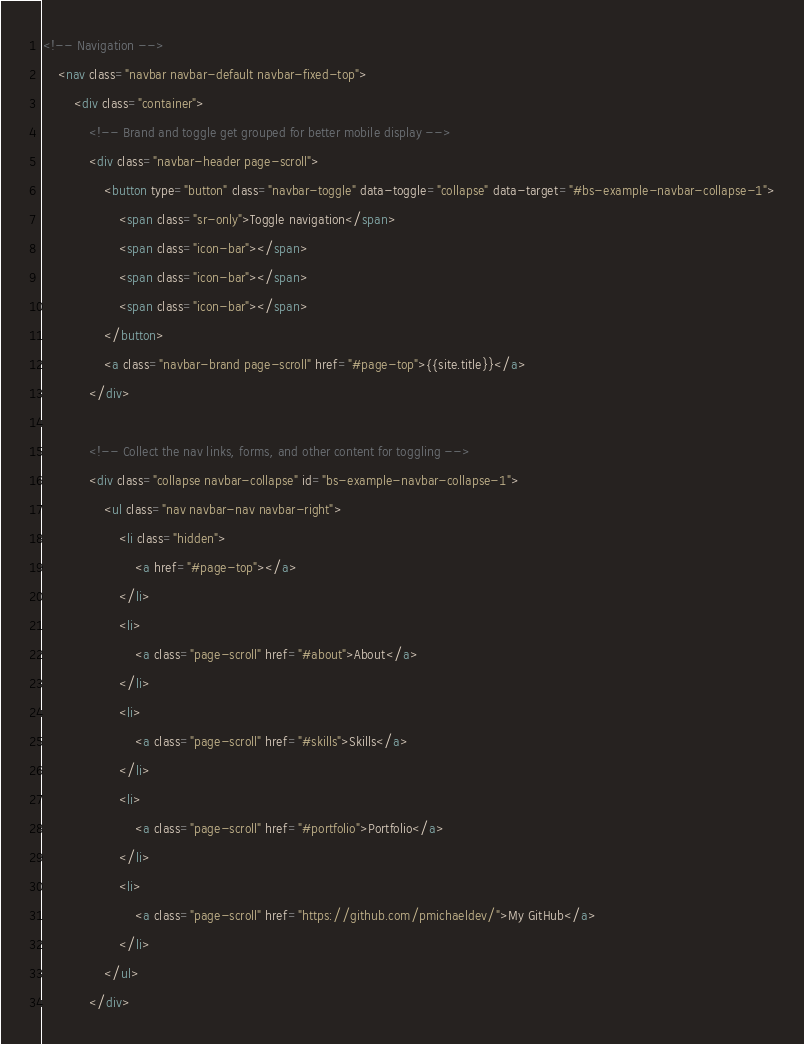Convert code to text. <code><loc_0><loc_0><loc_500><loc_500><_HTML_><!-- Navigation -->
    <nav class="navbar navbar-default navbar-fixed-top">
        <div class="container">
            <!-- Brand and toggle get grouped for better mobile display -->
            <div class="navbar-header page-scroll">
                <button type="button" class="navbar-toggle" data-toggle="collapse" data-target="#bs-example-navbar-collapse-1">
                    <span class="sr-only">Toggle navigation</span>
                    <span class="icon-bar"></span>
                    <span class="icon-bar"></span>
                    <span class="icon-bar"></span>
                </button>
                <a class="navbar-brand page-scroll" href="#page-top">{{site.title}}</a>
            </div>

            <!-- Collect the nav links, forms, and other content for toggling -->
            <div class="collapse navbar-collapse" id="bs-example-navbar-collapse-1">
                <ul class="nav navbar-nav navbar-right">
                    <li class="hidden">
                        <a href="#page-top"></a>
                    </li>
                    <li>
                        <a class="page-scroll" href="#about">About</a>
                    </li>
                    <li>
                        <a class="page-scroll" href="#skills">Skills</a>
                    </li>
                    <li>
                        <a class="page-scroll" href="#portfolio">Portfolio</a>
                    </li>
                    <li>
                        <a class="page-scroll" href="https://github.com/pmichaeldev/">My GitHub</a>
                    </li>
                </ul>
            </div></code> 